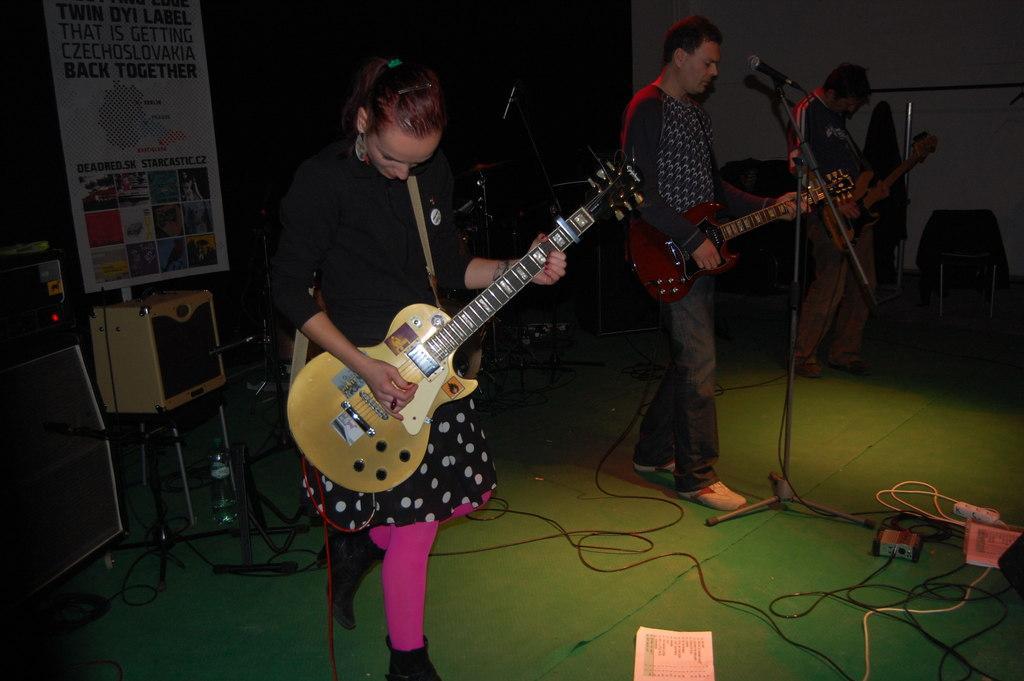Please provide a concise description of this image. The women wearing black dress is playing guitar and there are two other persons playing guitar in front of the mic beside her. 